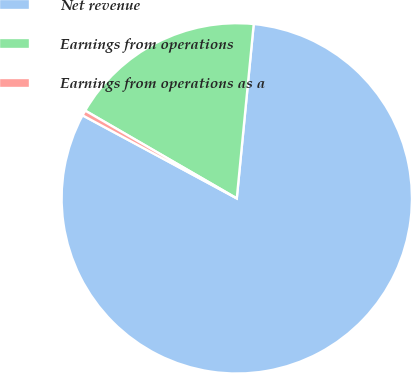Convert chart to OTSL. <chart><loc_0><loc_0><loc_500><loc_500><pie_chart><fcel>Net revenue<fcel>Earnings from operations<fcel>Earnings from operations as a<nl><fcel>81.32%<fcel>18.19%<fcel>0.49%<nl></chart> 